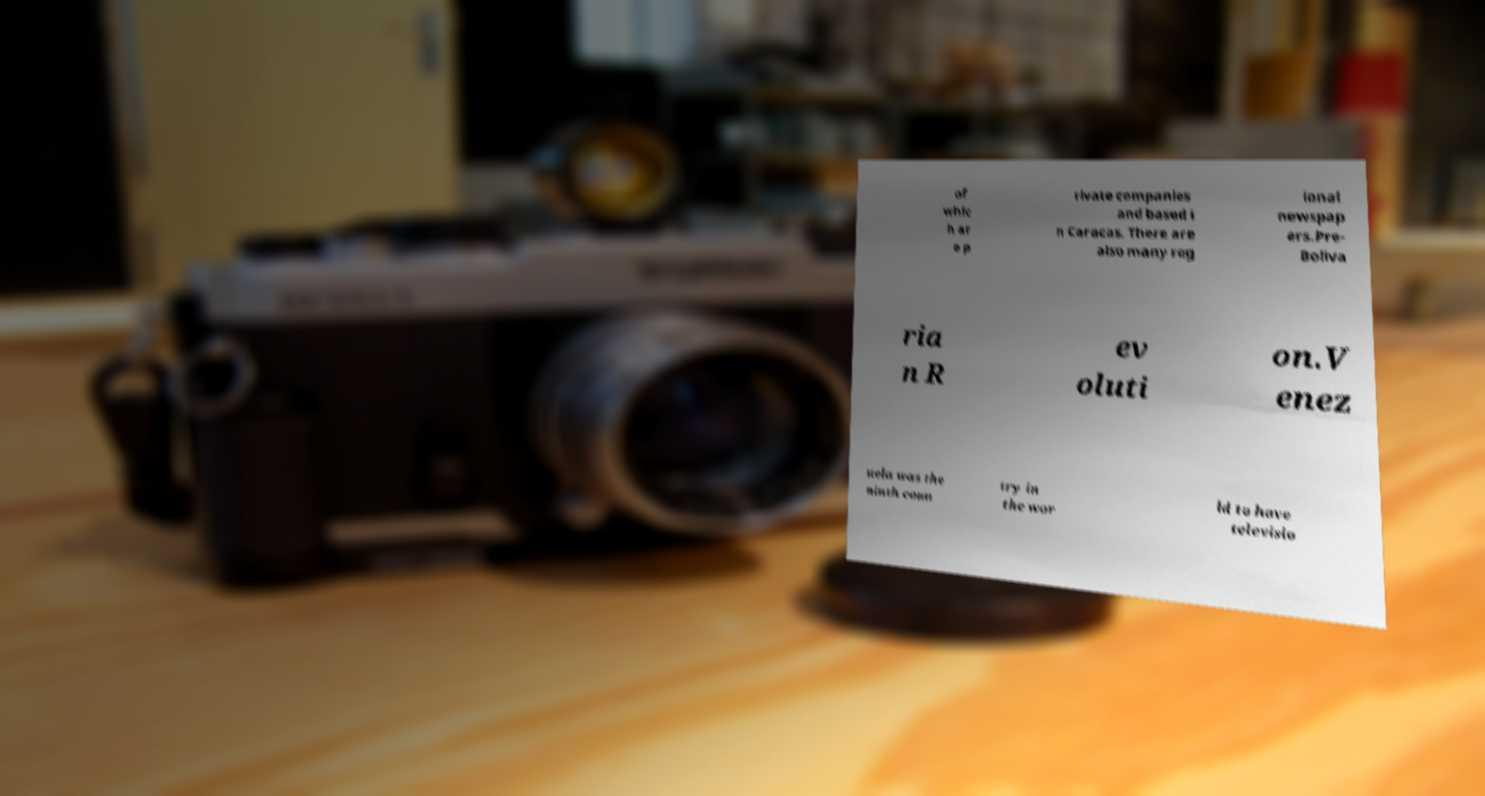Can you accurately transcribe the text from the provided image for me? of whic h ar e p rivate companies and based i n Caracas. There are also many reg ional newspap ers.Pre- Boliva ria n R ev oluti on.V enez uela was the ninth coun try in the wor ld to have televisio 